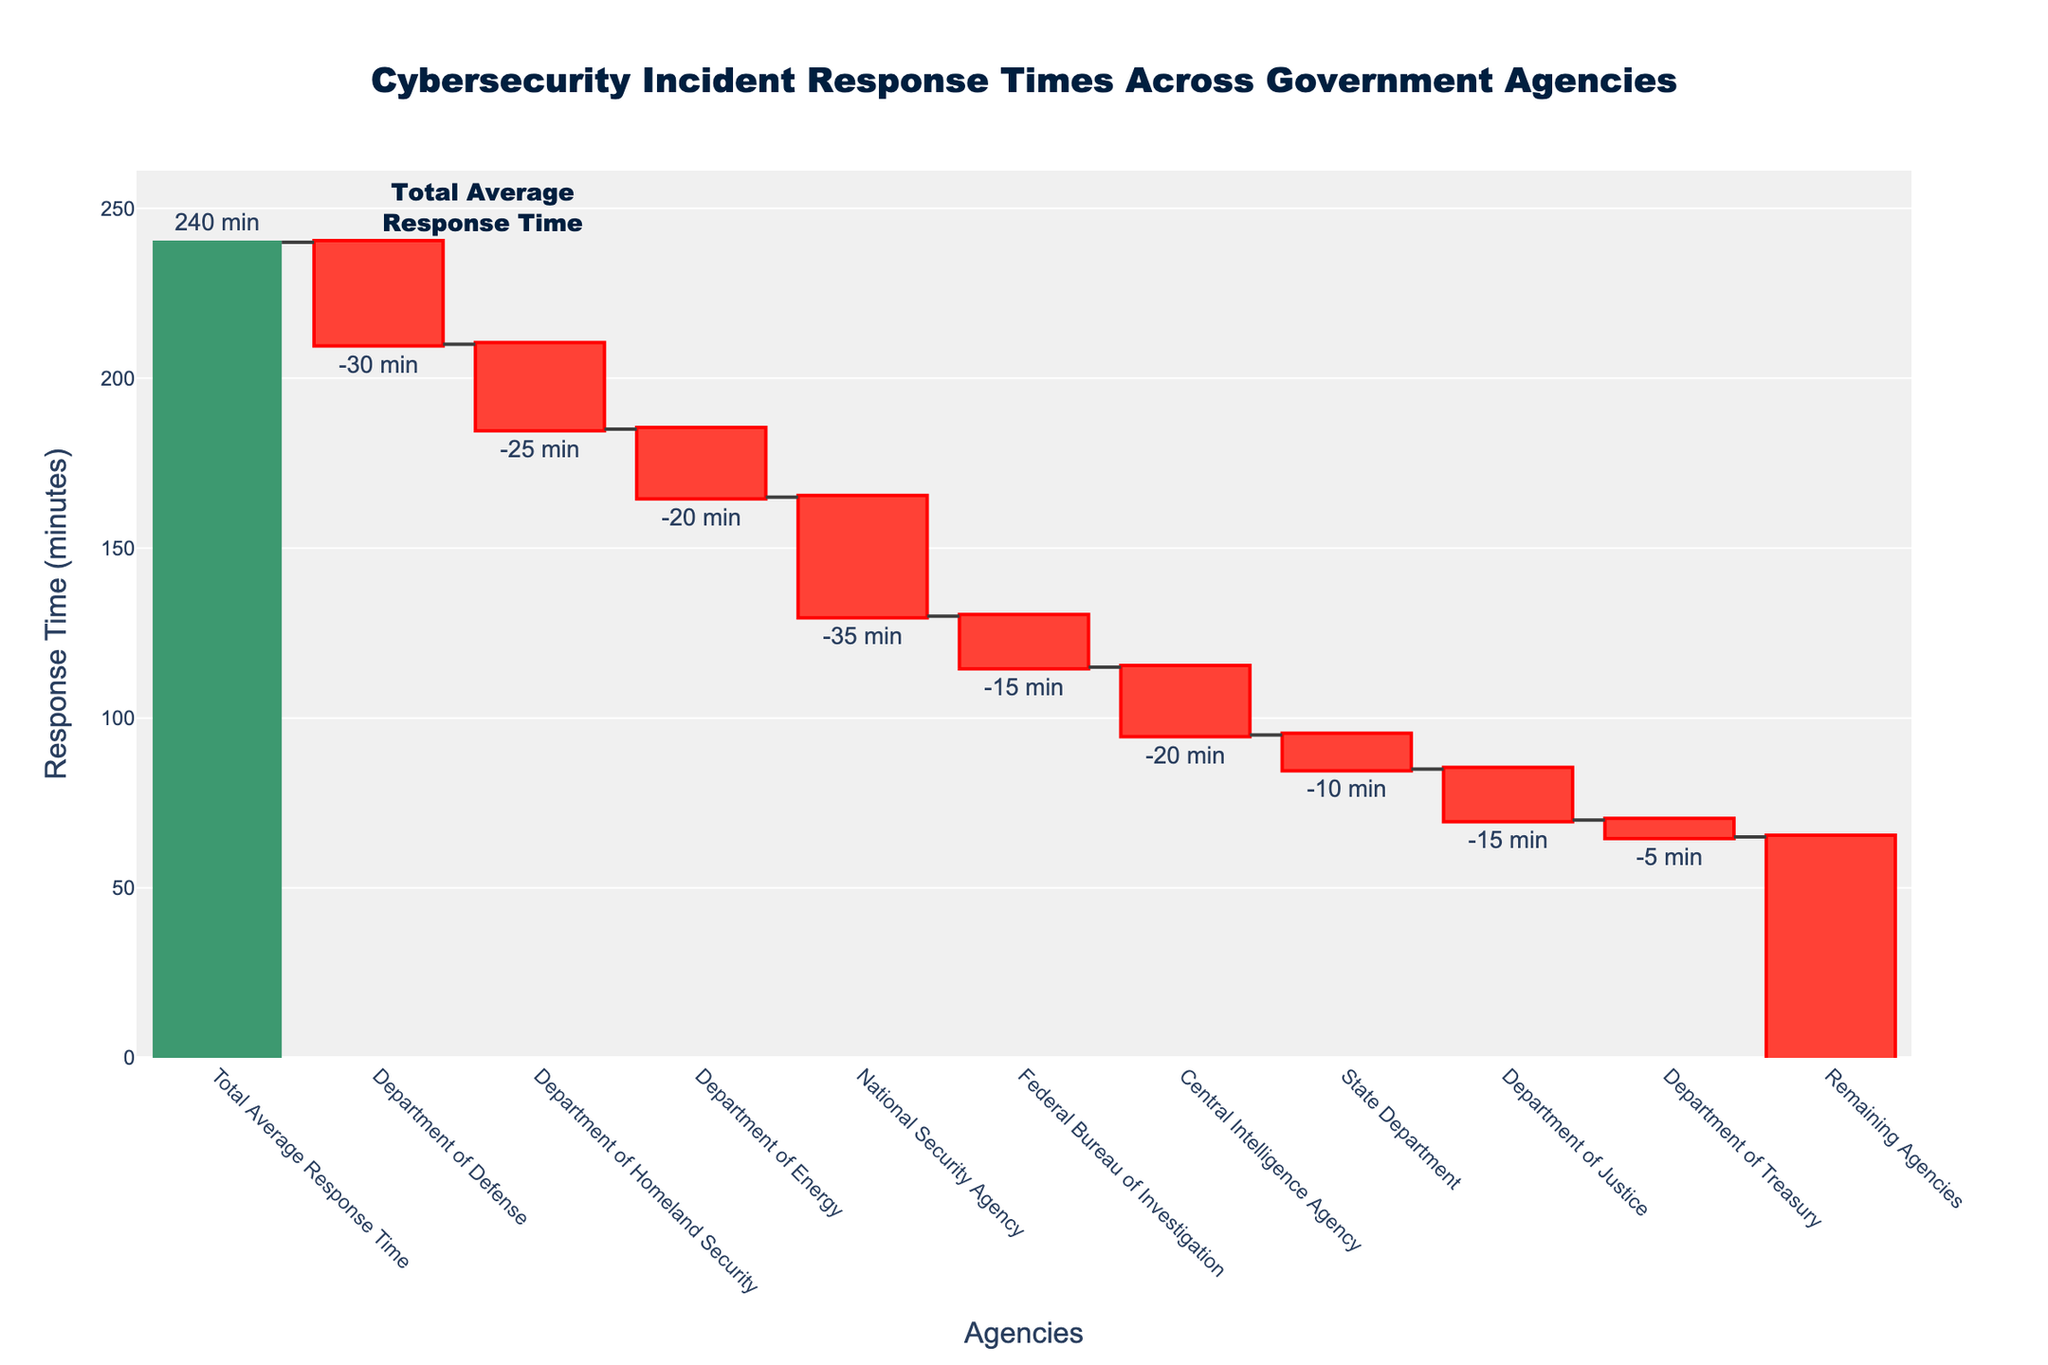What is the total average response time? The total average response time is shown at the top of the waterfall chart with the text "Total Average Response Time".
Answer: 240 minutes Which agency has the largest decrease in response time? The decrease is seen in negative values (bars going down). The National Security Agency (NSA) has the largest negative value of -35 minutes.
Answer: National Security Agency How much did the Department of Defense reduce the response time? The Department of Defense reduced the response time by observing its value which is -30 minutes.
Answer: 30 minutes What is the combined response time reduction of the Department of Energy and the Central Intelligence Agency? Sum the reductions of both agencies: Department of Energy (-20 minutes) + Central Intelligence Agency (-20 minutes).
Answer: 40 minutes Which two agencies combined have reduced the response time equal to the combined reduction of the Department of Homeland Security and Department of Defense? Find two agencies whose reductions sum to the combined reductions of DHS and DoD, which is -25 minutes (DHS) + -30 minutes (DoD) = -55 minutes. The National Security Agency (-35 minutes) and Remaining Agencies (-65 minutes) combined equals -55 minutes.
Answer: National Security Agency and Remaining Agencies What is the total decrease in response time due to the National Security Agency and the Department of Justice? Sum the decreases for both agencies: National Security Agency (-35 minutes) + Department of Justice (-15 minutes).
Answer: 50 minutes By how many minutes did the Federal Bureau of Investigation (FBI) decrease the response time? Find the value associated with the FBI which shows the response time decrease.
Answer: 15 minutes Which agency contributed the smallest reduction in response time? Identify the agency with the smallest negative value, which is the Department of Treasury with -5 minutes.
Answer: Department of Treasury How much did the remaining agencies contribute to the total decrease in response time? Look at the "Remaining Agencies" category and find its value.
Answer: 65 minutes 